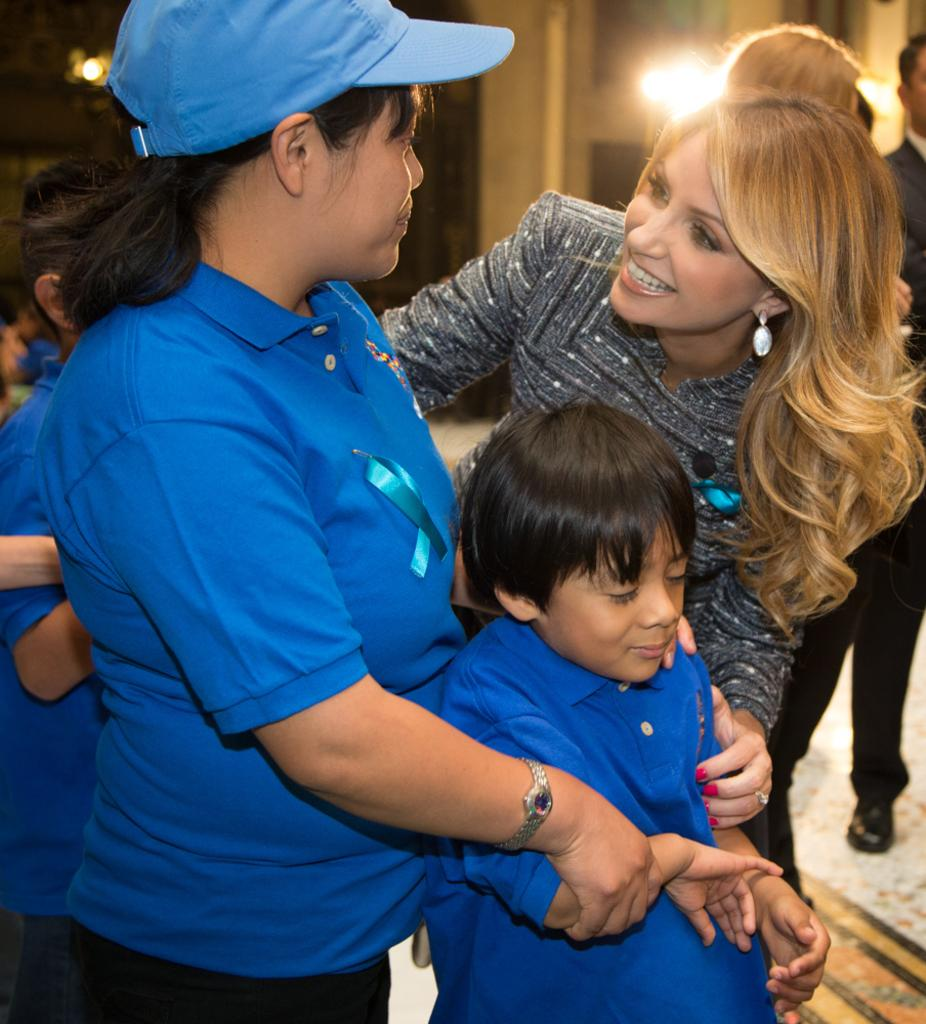What can be seen in the foreground of the image? There are people standing in the foreground of the image. What is visible in the background of the image? There is a wall and lights in the background of the image. What is the surface on which the people are standing? There is a floor at the bottom of the image. What type of crib is being used by the people in the image? There is no crib present in the image. How many chairs can be seen in the image? There is no mention of chairs in the provided facts, so we cannot determine the number of chairs in the image. 